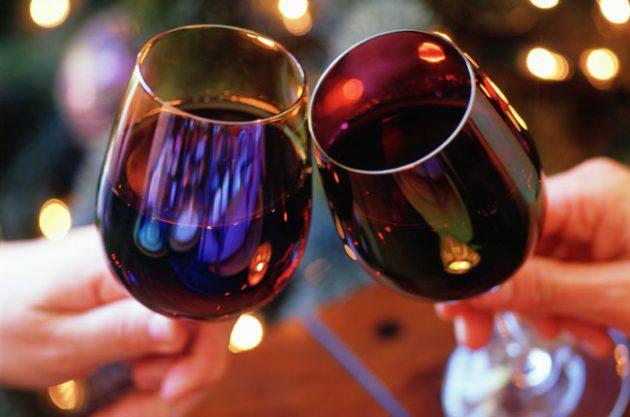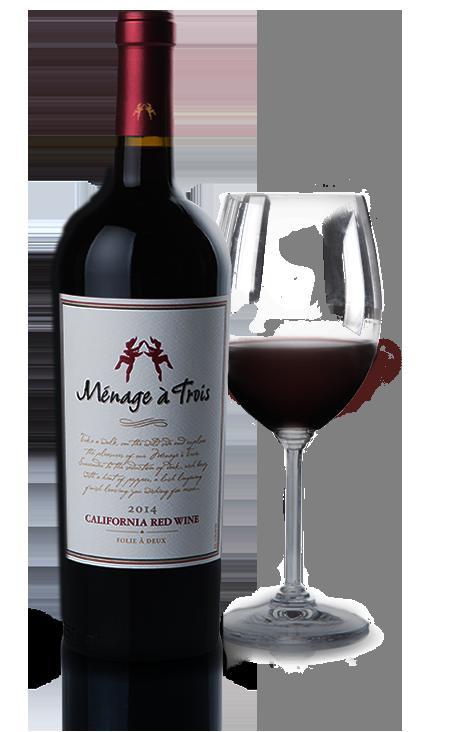The first image is the image on the left, the second image is the image on the right. Examine the images to the left and right. Is the description "Wine is pouring from a bottle into a glass in the left image." accurate? Answer yes or no. No. The first image is the image on the left, the second image is the image on the right. Given the left and right images, does the statement "In one of the images, red wine is being poured into a wine glass" hold true? Answer yes or no. No. 